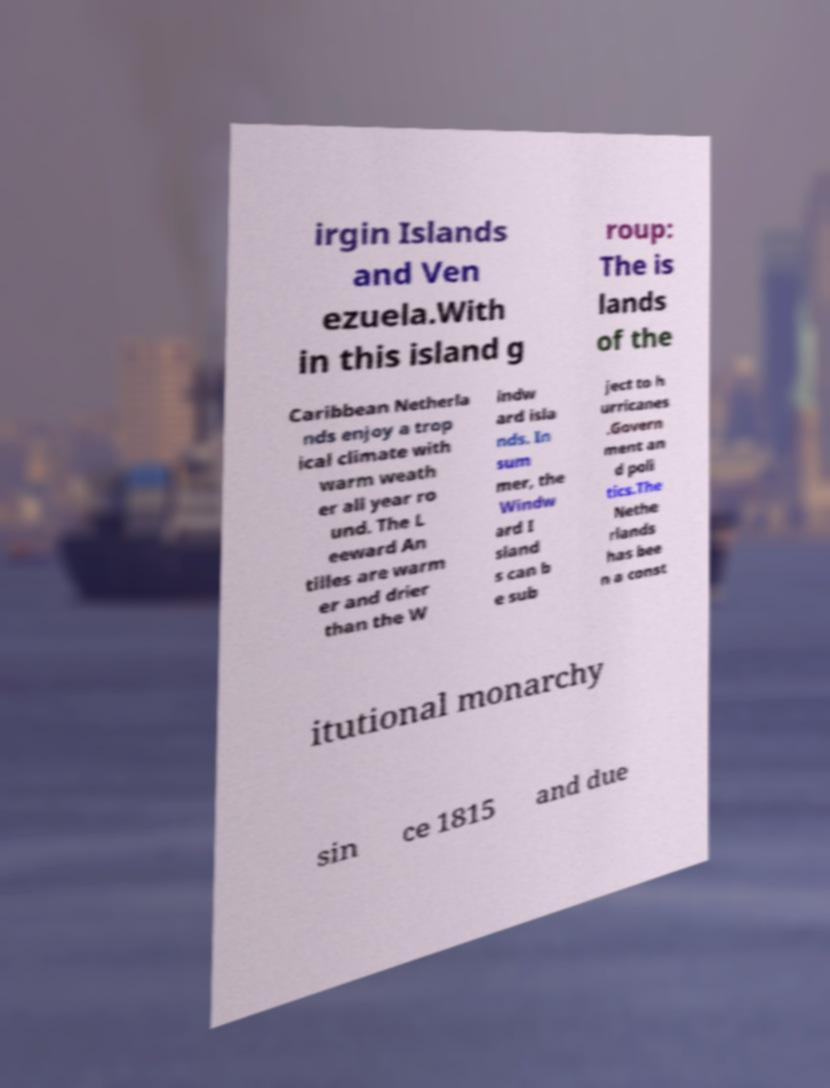There's text embedded in this image that I need extracted. Can you transcribe it verbatim? irgin Islands and Ven ezuela.With in this island g roup: The is lands of the Caribbean Netherla nds enjoy a trop ical climate with warm weath er all year ro und. The L eeward An tilles are warm er and drier than the W indw ard isla nds. In sum mer, the Windw ard I sland s can b e sub ject to h urricanes .Govern ment an d poli tics.The Nethe rlands has bee n a const itutional monarchy sin ce 1815 and due 